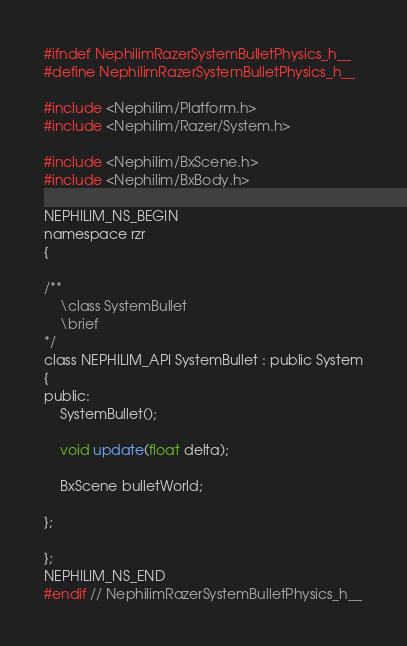<code> <loc_0><loc_0><loc_500><loc_500><_C_>#ifndef NephilimRazerSystemBulletPhysics_h__
#define NephilimRazerSystemBulletPhysics_h__

#include <Nephilim/Platform.h>
#include <Nephilim/Razer/System.h>

#include <Nephilim/BxScene.h>
#include <Nephilim/BxBody.h>

NEPHILIM_NS_BEGIN
namespace rzr 
{

/**
	\class SystemBullet
	\brief 
*/
class NEPHILIM_API SystemBullet : public System
{
public:
	SystemBullet();

	void update(float delta);

	BxScene bulletWorld;

};

};
NEPHILIM_NS_END
#endif // NephilimRazerSystemBulletPhysics_h__
</code> 